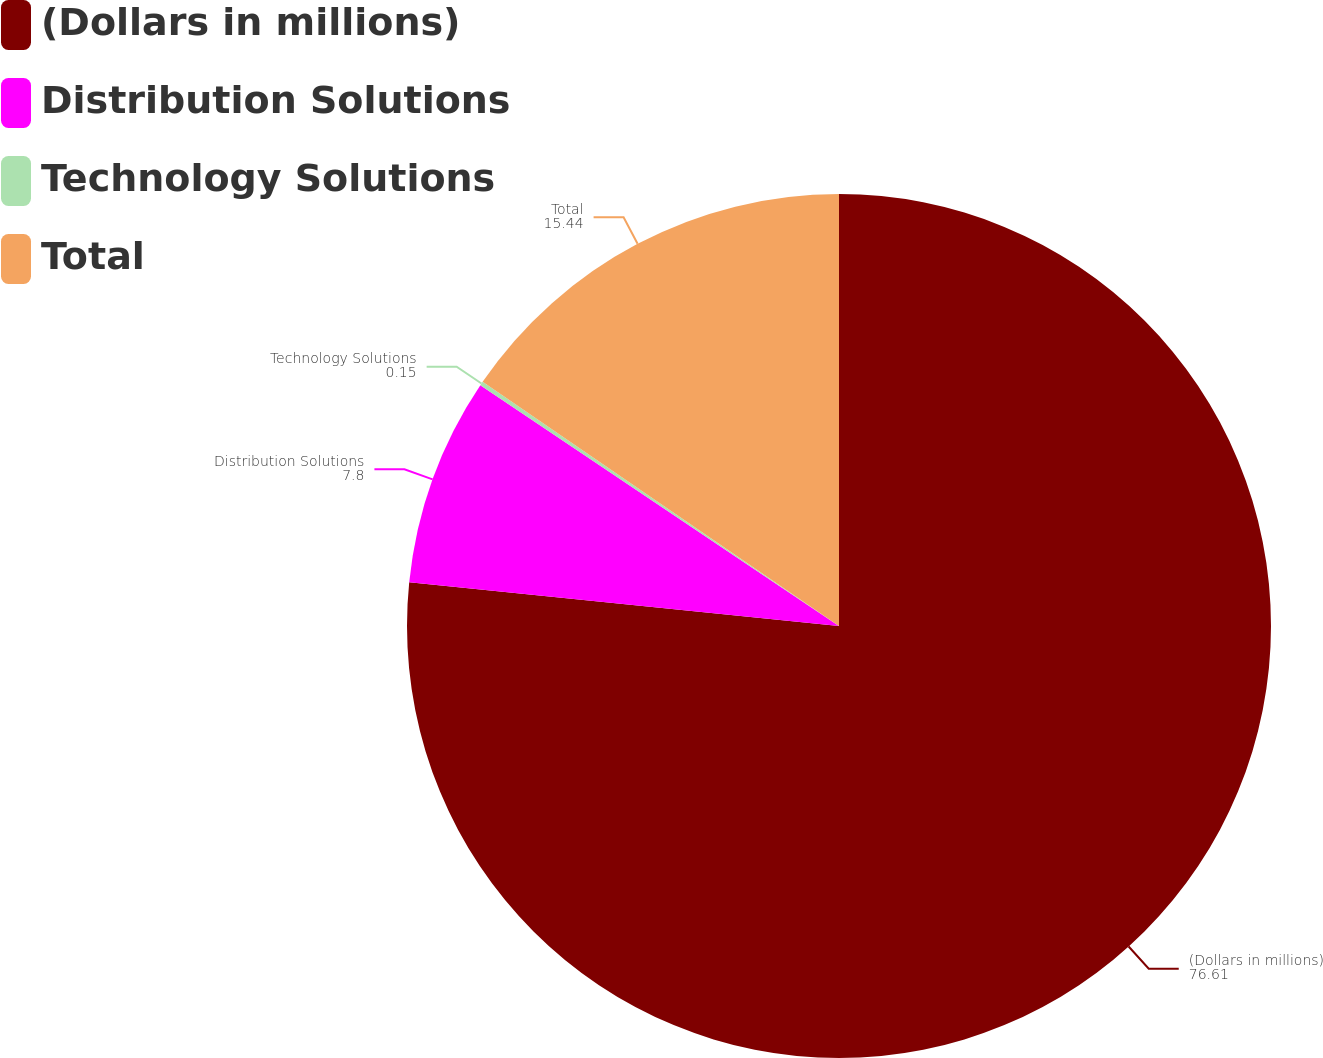Convert chart to OTSL. <chart><loc_0><loc_0><loc_500><loc_500><pie_chart><fcel>(Dollars in millions)<fcel>Distribution Solutions<fcel>Technology Solutions<fcel>Total<nl><fcel>76.61%<fcel>7.8%<fcel>0.15%<fcel>15.44%<nl></chart> 